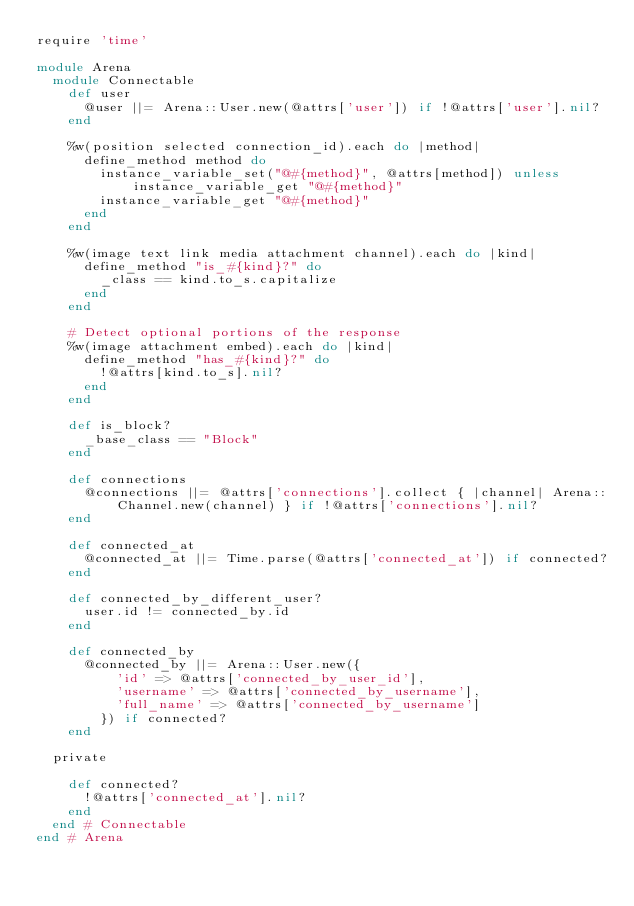Convert code to text. <code><loc_0><loc_0><loc_500><loc_500><_Ruby_>require 'time'

module Arena
  module Connectable
    def user
      @user ||= Arena::User.new(@attrs['user']) if !@attrs['user'].nil?
    end

    %w(position selected connection_id).each do |method|
      define_method method do
        instance_variable_set("@#{method}", @attrs[method]) unless instance_variable_get "@#{method}"
        instance_variable_get "@#{method}"
      end
    end

    %w(image text link media attachment channel).each do |kind|
      define_method "is_#{kind}?" do
        _class == kind.to_s.capitalize
      end
    end

    # Detect optional portions of the response
    %w(image attachment embed).each do |kind|
      define_method "has_#{kind}?" do
        !@attrs[kind.to_s].nil?
      end
    end

    def is_block?
      _base_class == "Block"
    end

    def connections
      @connections ||= @attrs['connections'].collect { |channel| Arena::Channel.new(channel) } if !@attrs['connections'].nil?
    end

    def connected_at
      @connected_at ||= Time.parse(@attrs['connected_at']) if connected?
    end

    def connected_by_different_user?
      user.id != connected_by.id
    end

    def connected_by
      @connected_by ||= Arena::User.new({
          'id' => @attrs['connected_by_user_id'],
          'username' => @attrs['connected_by_username'],
          'full_name' => @attrs['connected_by_username']
        }) if connected?
    end

  private

    def connected?
      !@attrs['connected_at'].nil?
    end
  end # Connectable
end # Arena
</code> 